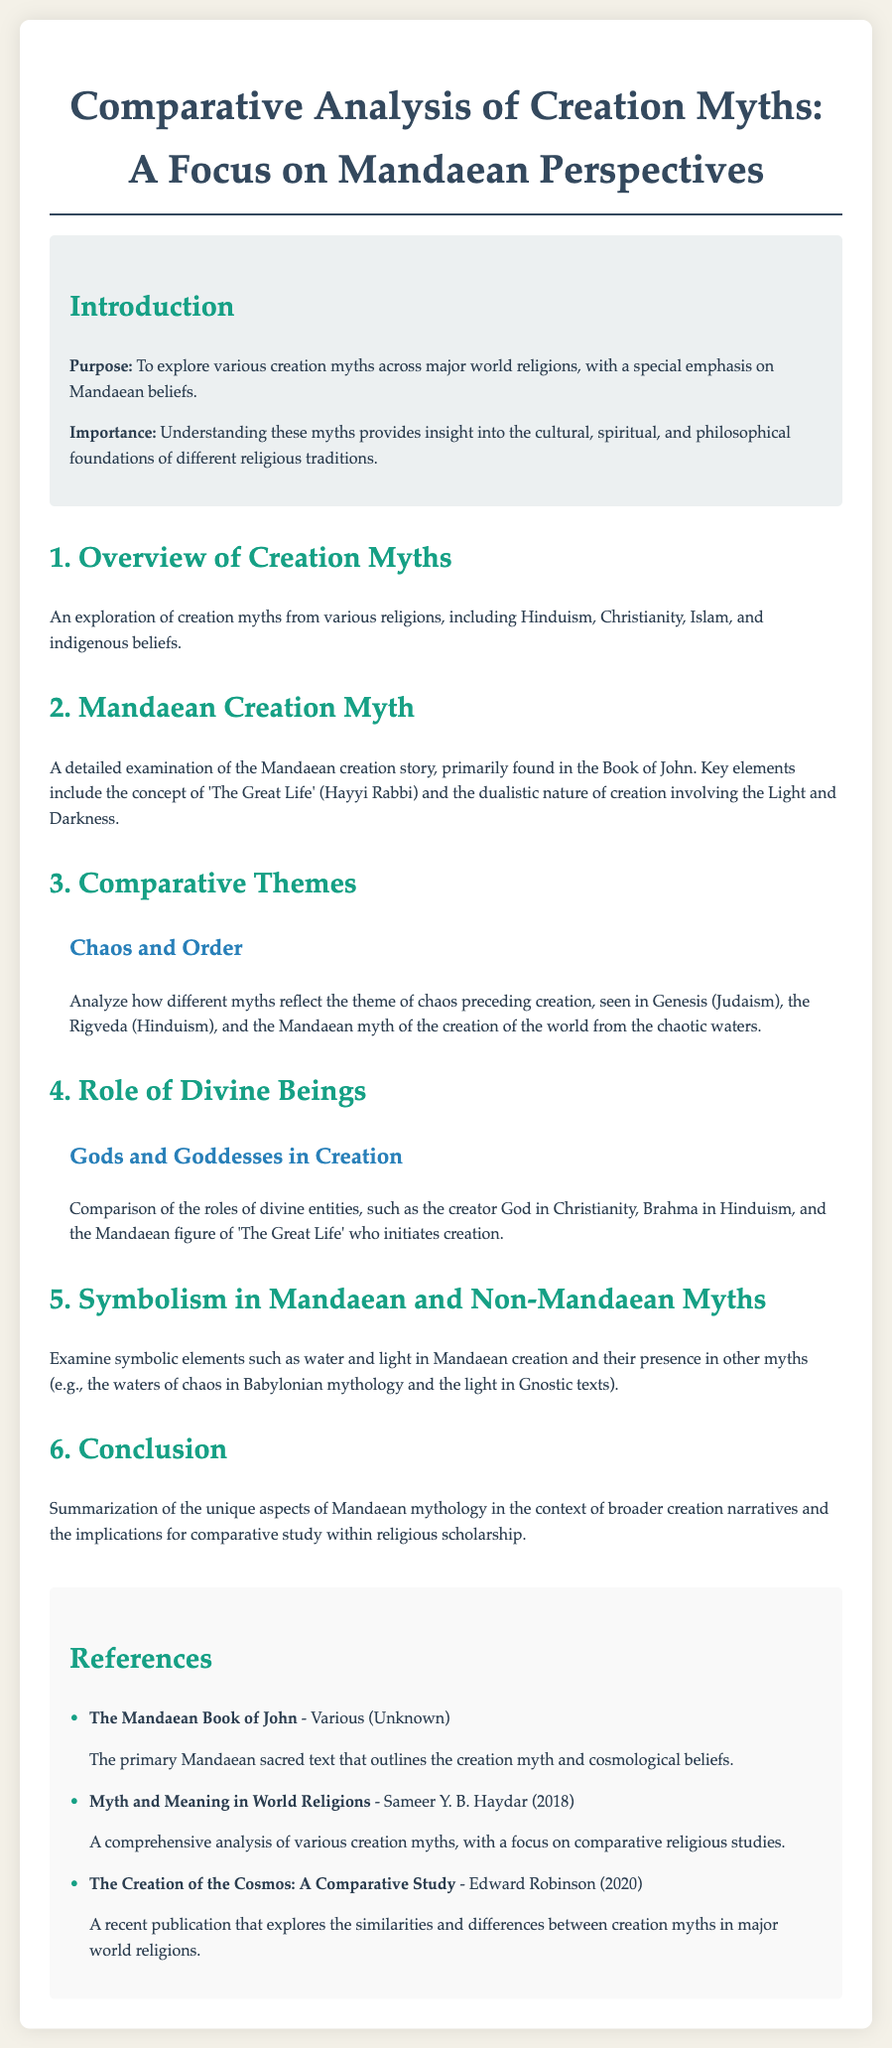What is the purpose of the document? The purpose is stated as exploring various creation myths across major world religions, with a special emphasis on Mandaean beliefs.
Answer: To explore various creation myths across major world religions What is the primary Mandaean sacred text mentioned? The document identifies "The Mandaean Book of John" as the primary sacred text that outlines Mandaean creation myth and cosmological beliefs.
Answer: The Mandaean Book of John Which two elements are symbolically examined in Mandaean creation? The document mentions water and light as symbolic elements in Mandaean creation.
Answer: Water and light What is highlighted in the section about the role of divine beings? The section compares the roles of divine entities such as the creator God in Christianity and Brahma in Hinduism, alongside the Mandaean figure of 'The Great Life'.
Answer: The roles of divine entities What theme is explored related to chaos and order? The document analyzes how myths reflect the theme of chaos preceding creation, evident in Genesis, the Rigveda, and the Mandaean myth.
Answer: Chaos preceding creation 